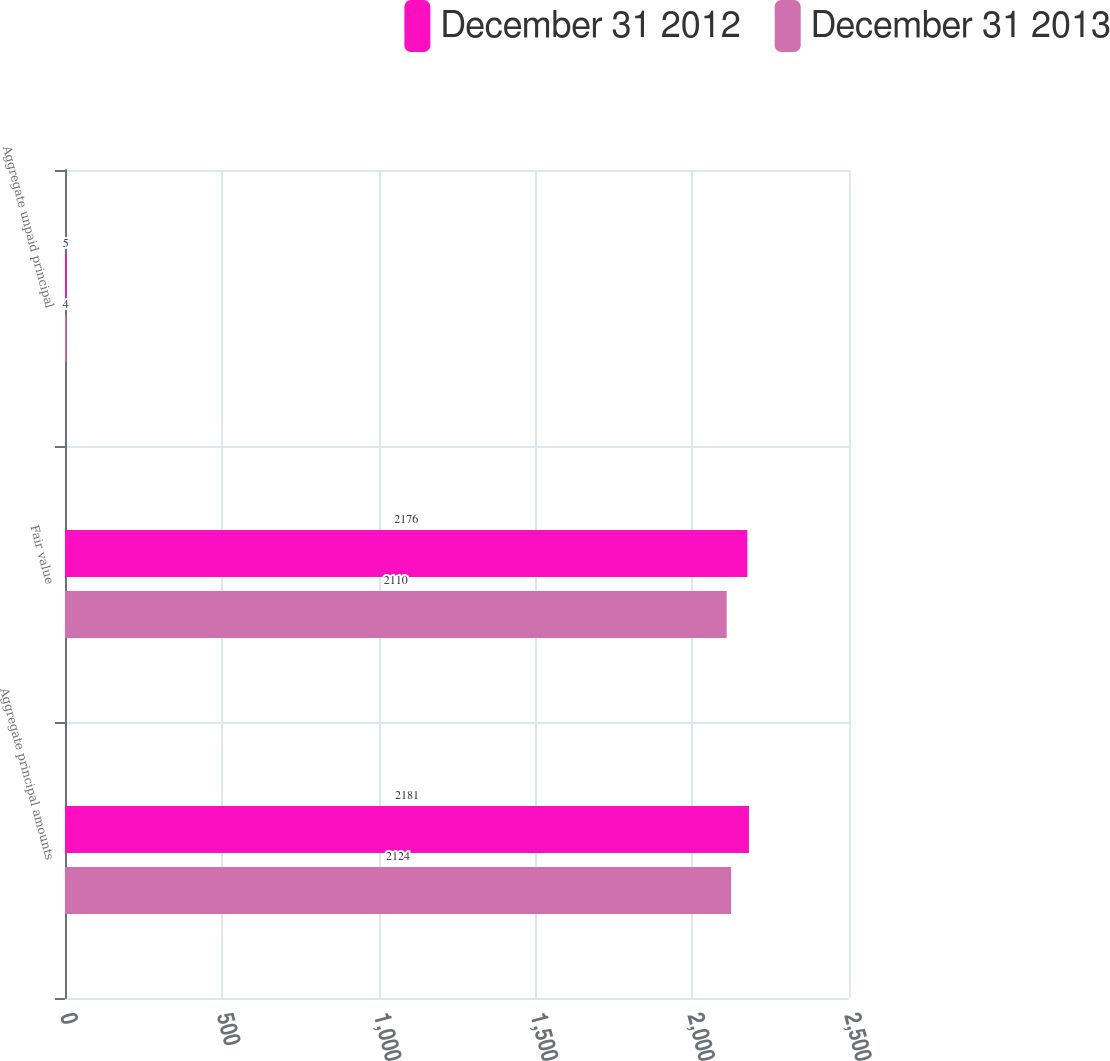<chart> <loc_0><loc_0><loc_500><loc_500><stacked_bar_chart><ecel><fcel>Aggregate principal amounts<fcel>Fair value<fcel>Aggregate unpaid principal<nl><fcel>December 31 2012<fcel>2181<fcel>2176<fcel>5<nl><fcel>December 31 2013<fcel>2124<fcel>2110<fcel>4<nl></chart> 